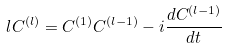Convert formula to latex. <formula><loc_0><loc_0><loc_500><loc_500>l C ^ { ( l ) } = C ^ { ( 1 ) } C ^ { ( l - 1 ) } - i \frac { d C ^ { ( l - 1 ) } } { d t }</formula> 